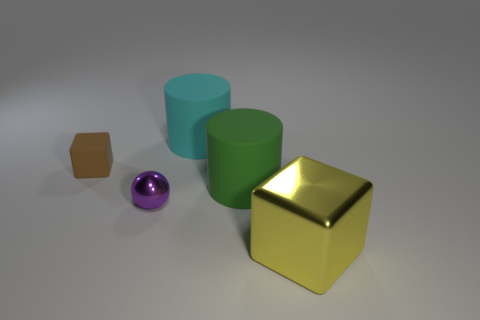Can you tell the position of the light source based on the shadows in the image? The light source appears to be located above the objects towards the left side of the frame, as indicated by the direction of the shadows cast to the right of the objects. 